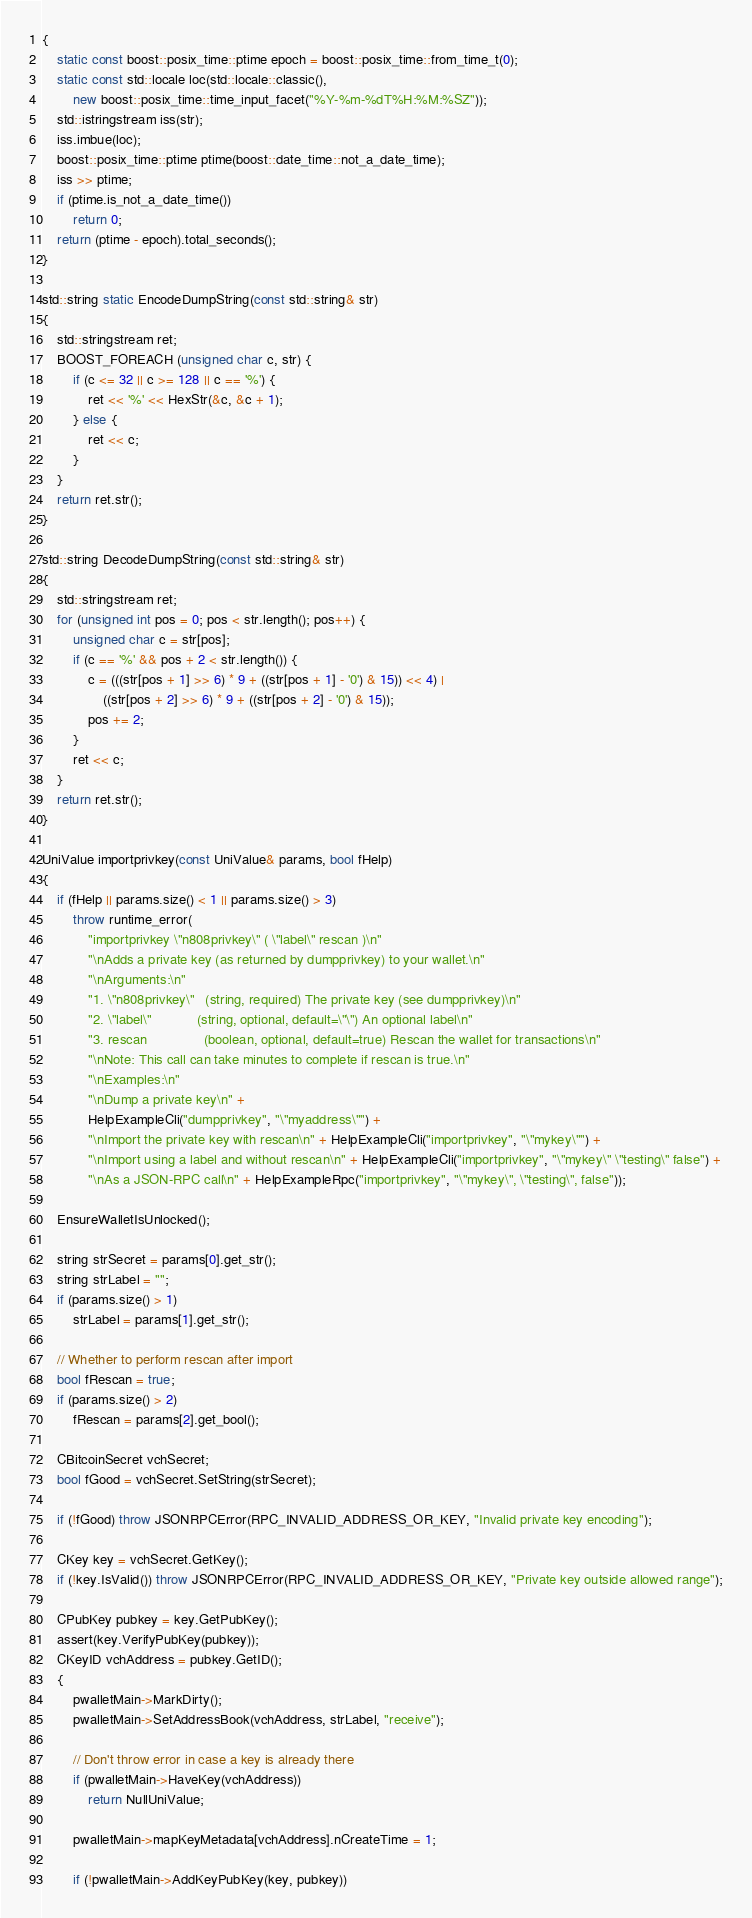<code> <loc_0><loc_0><loc_500><loc_500><_C++_>{
    static const boost::posix_time::ptime epoch = boost::posix_time::from_time_t(0);
    static const std::locale loc(std::locale::classic(),
        new boost::posix_time::time_input_facet("%Y-%m-%dT%H:%M:%SZ"));
    std::istringstream iss(str);
    iss.imbue(loc);
    boost::posix_time::ptime ptime(boost::date_time::not_a_date_time);
    iss >> ptime;
    if (ptime.is_not_a_date_time())
        return 0;
    return (ptime - epoch).total_seconds();
}

std::string static EncodeDumpString(const std::string& str)
{
    std::stringstream ret;
    BOOST_FOREACH (unsigned char c, str) {
        if (c <= 32 || c >= 128 || c == '%') {
            ret << '%' << HexStr(&c, &c + 1);
        } else {
            ret << c;
        }
    }
    return ret.str();
}

std::string DecodeDumpString(const std::string& str)
{
    std::stringstream ret;
    for (unsigned int pos = 0; pos < str.length(); pos++) {
        unsigned char c = str[pos];
        if (c == '%' && pos + 2 < str.length()) {
            c = (((str[pos + 1] >> 6) * 9 + ((str[pos + 1] - '0') & 15)) << 4) |
                ((str[pos + 2] >> 6) * 9 + ((str[pos + 2] - '0') & 15));
            pos += 2;
        }
        ret << c;
    }
    return ret.str();
}

UniValue importprivkey(const UniValue& params, bool fHelp)
{
    if (fHelp || params.size() < 1 || params.size() > 3)
        throw runtime_error(
            "importprivkey \"n808privkey\" ( \"label\" rescan )\n"
            "\nAdds a private key (as returned by dumpprivkey) to your wallet.\n"
            "\nArguments:\n"
            "1. \"n808privkey\"   (string, required) The private key (see dumpprivkey)\n"
            "2. \"label\"            (string, optional, default=\"\") An optional label\n"
            "3. rescan               (boolean, optional, default=true) Rescan the wallet for transactions\n"
            "\nNote: This call can take minutes to complete if rescan is true.\n"
            "\nExamples:\n"
            "\nDump a private key\n" +
            HelpExampleCli("dumpprivkey", "\"myaddress\"") +
            "\nImport the private key with rescan\n" + HelpExampleCli("importprivkey", "\"mykey\"") +
            "\nImport using a label and without rescan\n" + HelpExampleCli("importprivkey", "\"mykey\" \"testing\" false") +
            "\nAs a JSON-RPC call\n" + HelpExampleRpc("importprivkey", "\"mykey\", \"testing\", false"));

    EnsureWalletIsUnlocked();

    string strSecret = params[0].get_str();
    string strLabel = "";
    if (params.size() > 1)
        strLabel = params[1].get_str();

    // Whether to perform rescan after import
    bool fRescan = true;
    if (params.size() > 2)
        fRescan = params[2].get_bool();

    CBitcoinSecret vchSecret;
    bool fGood = vchSecret.SetString(strSecret);

    if (!fGood) throw JSONRPCError(RPC_INVALID_ADDRESS_OR_KEY, "Invalid private key encoding");

    CKey key = vchSecret.GetKey();
    if (!key.IsValid()) throw JSONRPCError(RPC_INVALID_ADDRESS_OR_KEY, "Private key outside allowed range");

    CPubKey pubkey = key.GetPubKey();
    assert(key.VerifyPubKey(pubkey));
    CKeyID vchAddress = pubkey.GetID();
    {
        pwalletMain->MarkDirty();
        pwalletMain->SetAddressBook(vchAddress, strLabel, "receive");

        // Don't throw error in case a key is already there
        if (pwalletMain->HaveKey(vchAddress))
            return NullUniValue;

        pwalletMain->mapKeyMetadata[vchAddress].nCreateTime = 1;

        if (!pwalletMain->AddKeyPubKey(key, pubkey))</code> 